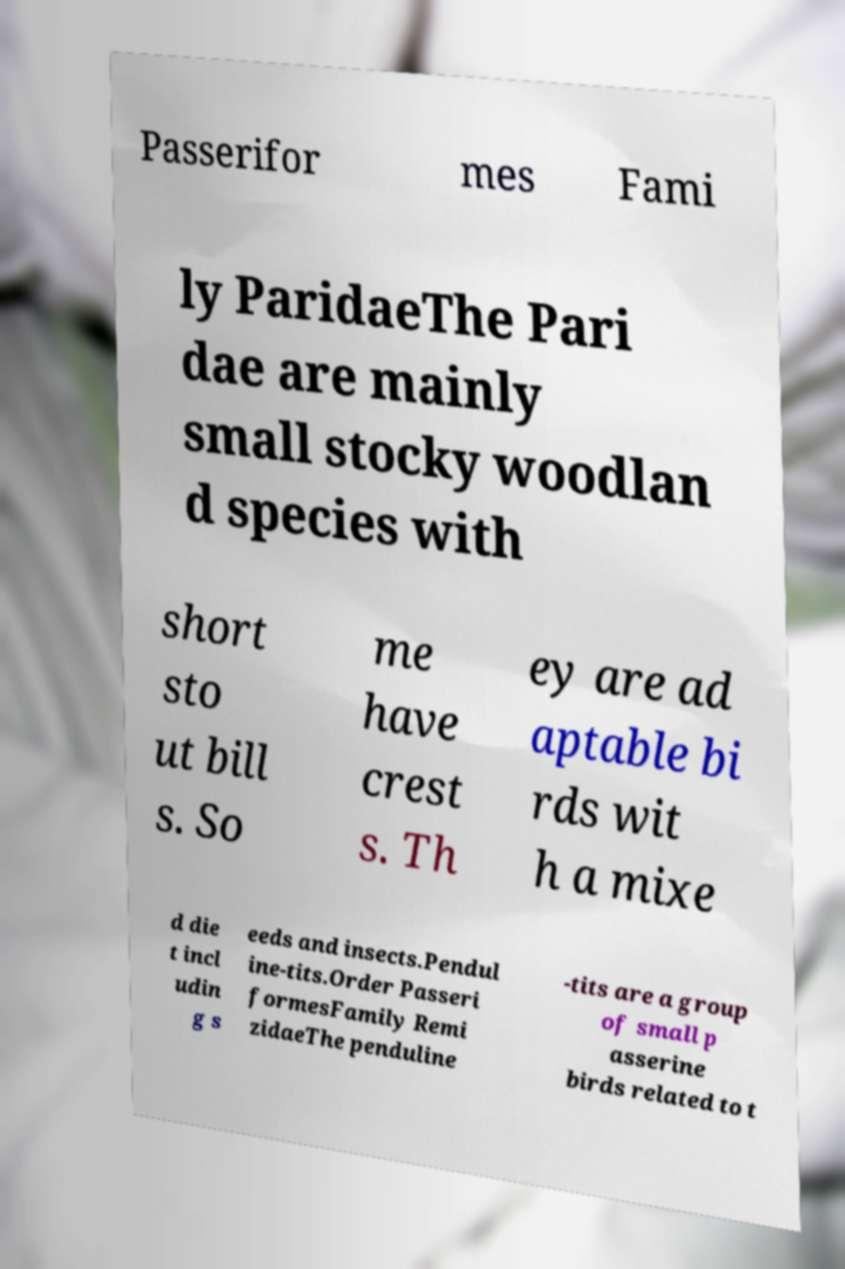Can you accurately transcribe the text from the provided image for me? Passerifor mes Fami ly ParidaeThe Pari dae are mainly small stocky woodlan d species with short sto ut bill s. So me have crest s. Th ey are ad aptable bi rds wit h a mixe d die t incl udin g s eeds and insects.Pendul ine-tits.Order Passeri formesFamily Remi zidaeThe penduline -tits are a group of small p asserine birds related to t 